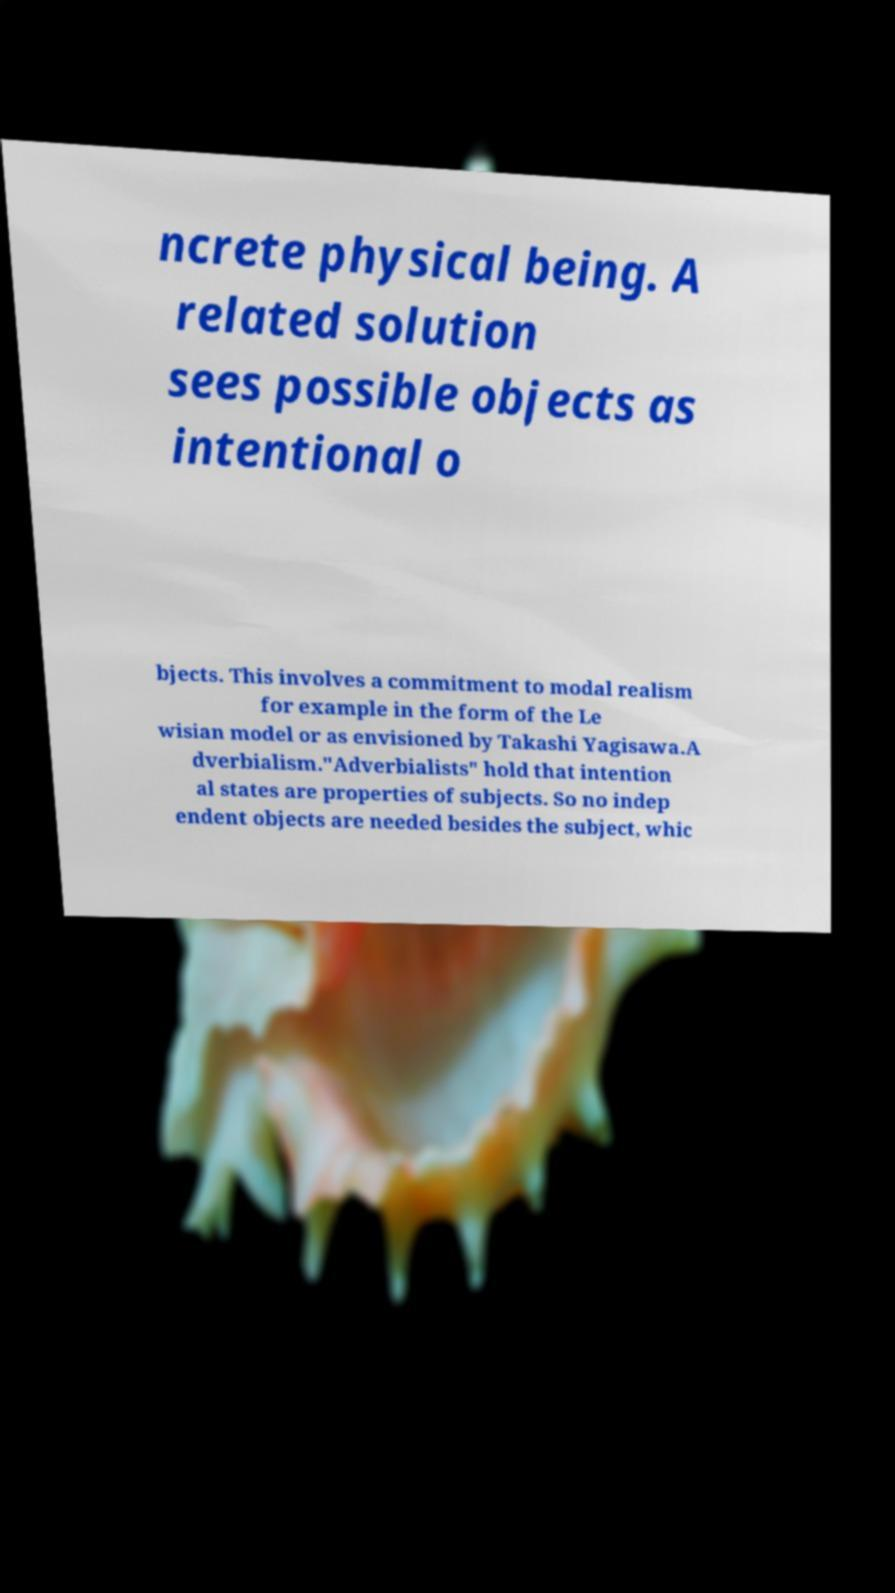Can you read and provide the text displayed in the image?This photo seems to have some interesting text. Can you extract and type it out for me? ncrete physical being. A related solution sees possible objects as intentional o bjects. This involves a commitment to modal realism for example in the form of the Le wisian model or as envisioned by Takashi Yagisawa.A dverbialism."Adverbialists" hold that intention al states are properties of subjects. So no indep endent objects are needed besides the subject, whic 